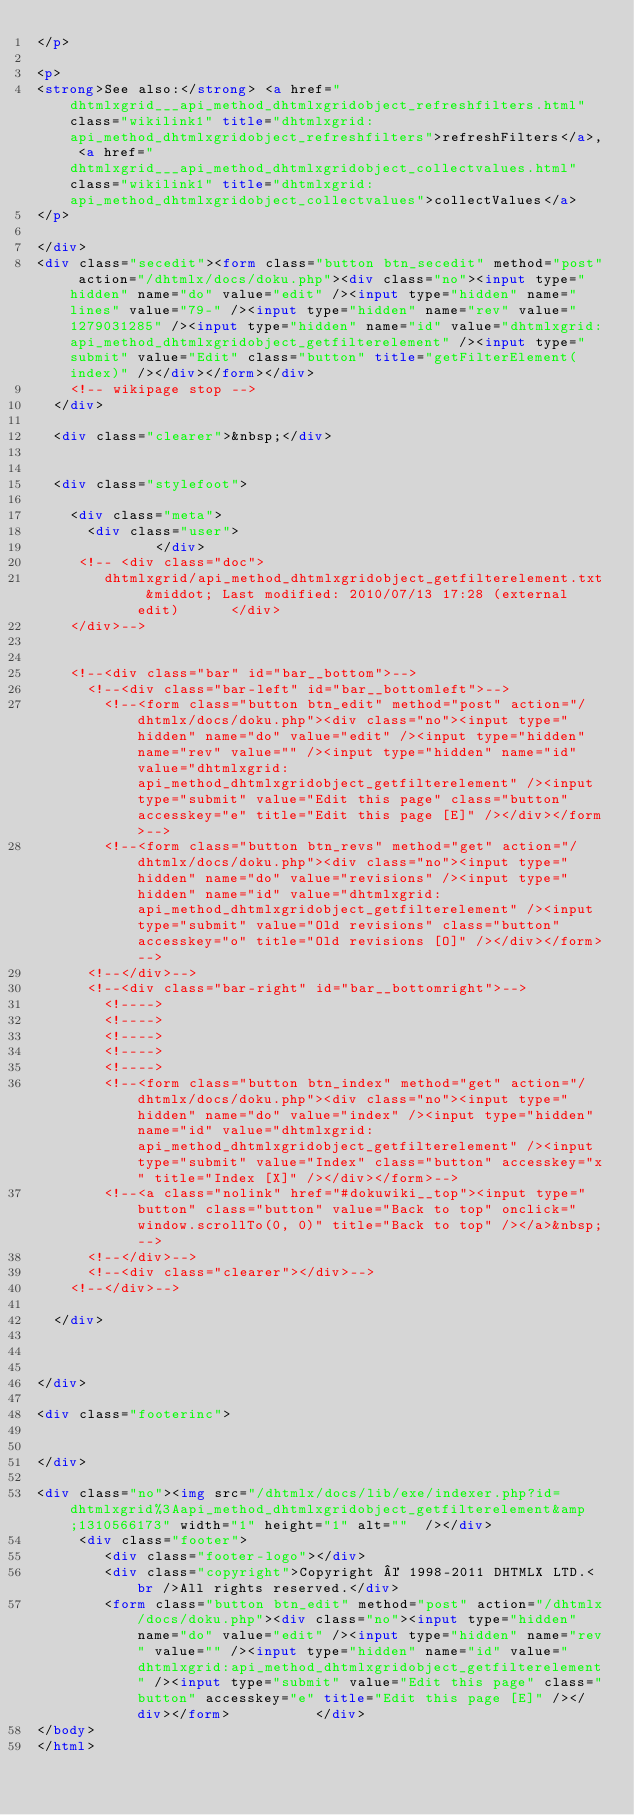<code> <loc_0><loc_0><loc_500><loc_500><_HTML_></p>

<p>
<strong>See also:</strong> <a href="dhtmlxgrid___api_method_dhtmlxgridobject_refreshfilters.html" class="wikilink1" title="dhtmlxgrid:api_method_dhtmlxgridobject_refreshfilters">refreshFilters</a>, <a href="dhtmlxgrid___api_method_dhtmlxgridobject_collectvalues.html" class="wikilink1" title="dhtmlxgrid:api_method_dhtmlxgridobject_collectvalues">collectValues</a>
</p>

</div>
<div class="secedit"><form class="button btn_secedit" method="post" action="/dhtmlx/docs/doku.php"><div class="no"><input type="hidden" name="do" value="edit" /><input type="hidden" name="lines" value="79-" /><input type="hidden" name="rev" value="1279031285" /><input type="hidden" name="id" value="dhtmlxgrid:api_method_dhtmlxgridobject_getfilterelement" /><input type="submit" value="Edit" class="button" title="getFilterElement(index)" /></div></form></div>
    <!-- wikipage stop -->
  </div>

  <div class="clearer">&nbsp;</div>

  
  <div class="stylefoot">

    <div class="meta">
      <div class="user">
              </div>
     <!-- <div class="doc">
        dhtmlxgrid/api_method_dhtmlxgridobject_getfilterelement.txt &middot; Last modified: 2010/07/13 17:28 (external edit)      </div>
    </div>-->

   
    <!--<div class="bar" id="bar__bottom">-->
      <!--<div class="bar-left" id="bar__bottomleft">-->
        <!--<form class="button btn_edit" method="post" action="/dhtmlx/docs/doku.php"><div class="no"><input type="hidden" name="do" value="edit" /><input type="hidden" name="rev" value="" /><input type="hidden" name="id" value="dhtmlxgrid:api_method_dhtmlxgridobject_getfilterelement" /><input type="submit" value="Edit this page" class="button" accesskey="e" title="Edit this page [E]" /></div></form>-->
        <!--<form class="button btn_revs" method="get" action="/dhtmlx/docs/doku.php"><div class="no"><input type="hidden" name="do" value="revisions" /><input type="hidden" name="id" value="dhtmlxgrid:api_method_dhtmlxgridobject_getfilterelement" /><input type="submit" value="Old revisions" class="button" accesskey="o" title="Old revisions [O]" /></div></form>-->
      <!--</div>-->
      <!--<div class="bar-right" id="bar__bottomright">-->
        <!---->
        <!---->
        <!---->
        <!---->
        <!---->
        <!--<form class="button btn_index" method="get" action="/dhtmlx/docs/doku.php"><div class="no"><input type="hidden" name="do" value="index" /><input type="hidden" name="id" value="dhtmlxgrid:api_method_dhtmlxgridobject_getfilterelement" /><input type="submit" value="Index" class="button" accesskey="x" title="Index [X]" /></div></form>-->
        <!--<a class="nolink" href="#dokuwiki__top"><input type="button" class="button" value="Back to top" onclick="window.scrollTo(0, 0)" title="Back to top" /></a>&nbsp;-->
      <!--</div>-->
      <!--<div class="clearer"></div>-->
    <!--</div>-->

  </div>

  

</div>

<div class="footerinc">


</div>

<div class="no"><img src="/dhtmlx/docs/lib/exe/indexer.php?id=dhtmlxgrid%3Aapi_method_dhtmlxgridobject_getfilterelement&amp;1310566173" width="1" height="1" alt=""  /></div>
     <div class="footer">
        <div class="footer-logo"></div>
        <div class="copyright">Copyright © 1998-2011 DHTMLX LTD.<br />All rights reserved.</div>
        <form class="button btn_edit" method="post" action="/dhtmlx/docs/doku.php"><div class="no"><input type="hidden" name="do" value="edit" /><input type="hidden" name="rev" value="" /><input type="hidden" name="id" value="dhtmlxgrid:api_method_dhtmlxgridobject_getfilterelement" /><input type="submit" value="Edit this page" class="button" accesskey="e" title="Edit this page [E]" /></div></form>    	    </div>
</body>
</html>
</code> 